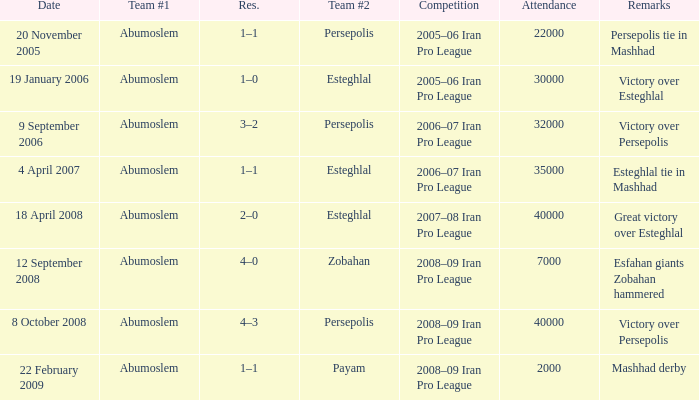Who was team #1 on 9 September 2006? Abumoslem. 